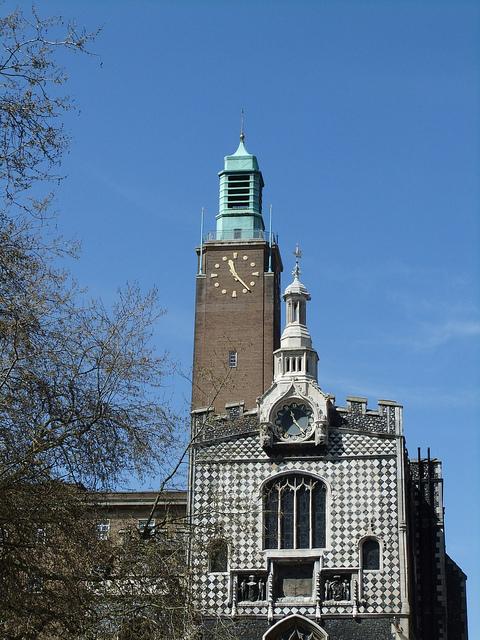What color is the clock on the tower?
Answer briefly. White. What time is on the clock?
Concise answer only. 11:23. Is it cloudy or sunny?
Write a very short answer. Sunny. What time is it?
Short answer required. 11:24. Is it daytime?
Write a very short answer. Yes. What religion is practiced at this church?
Quick response, please. Christianity. What is the blue object on the top of the building?
Quick response, please. Steeple. How many stories is the clock tower?
Short answer required. 3. Is this a castle?
Be succinct. No. What type of building is this?
Keep it brief. Church. 